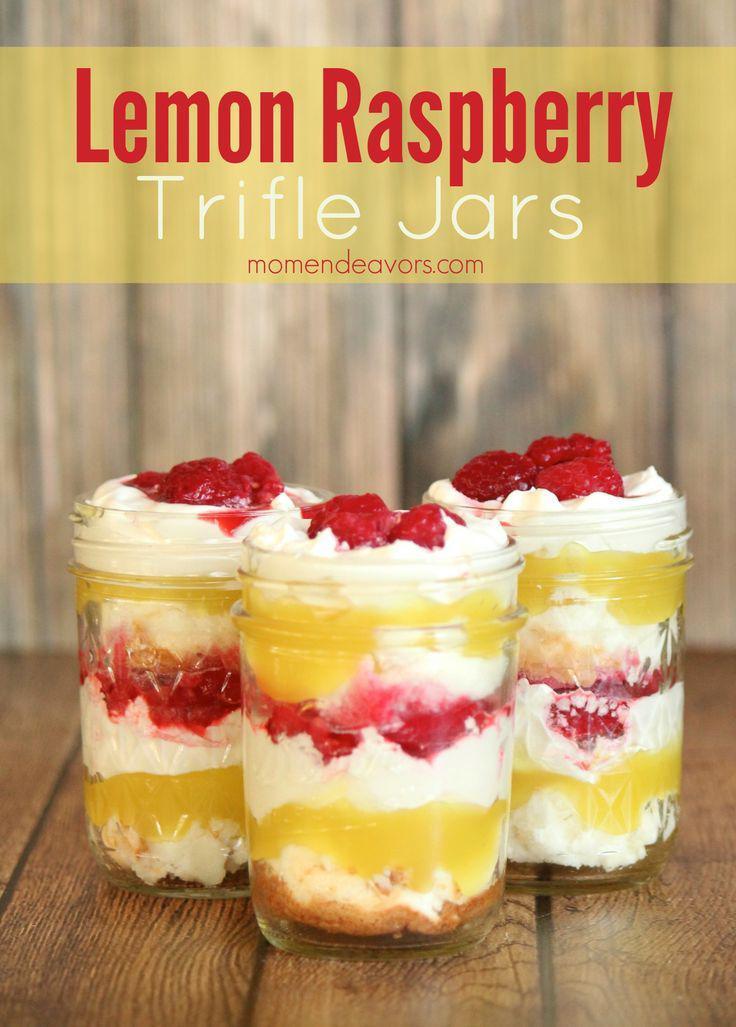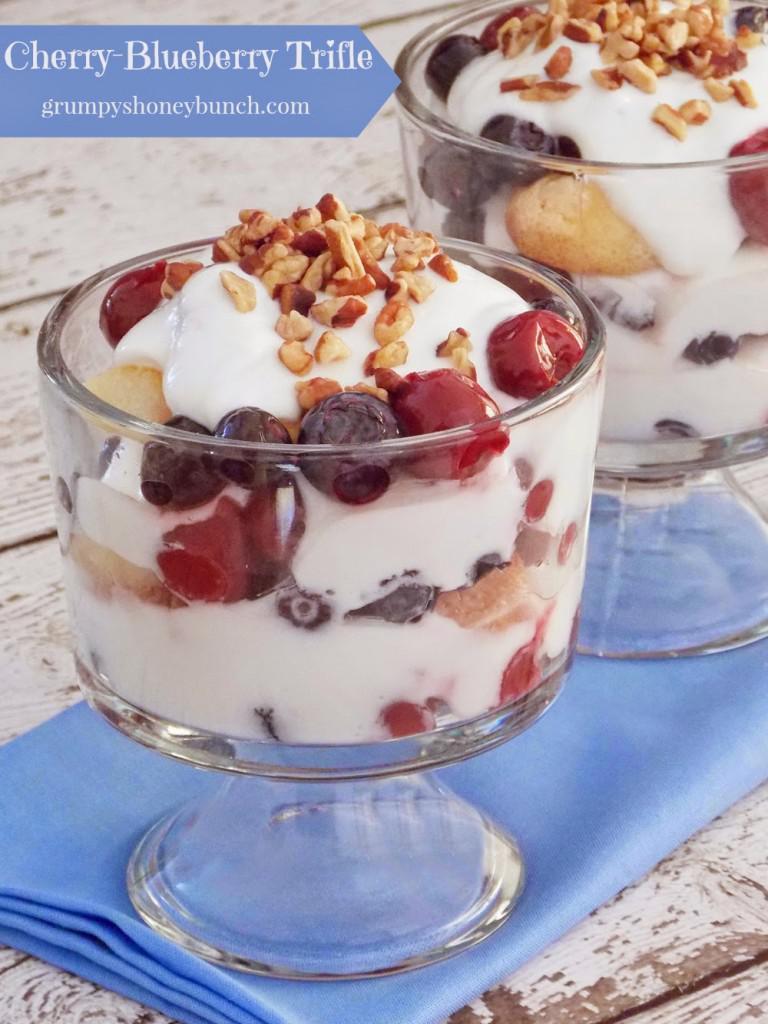The first image is the image on the left, the second image is the image on the right. Considering the images on both sides, is "An image shows a whipped cream-topped dessert in a jar next to unpeeled bananas." valid? Answer yes or no. No. The first image is the image on the left, the second image is the image on the right. Evaluate the accuracy of this statement regarding the images: "A banana is shown near at least one of the desserts.". Is it true? Answer yes or no. No. 